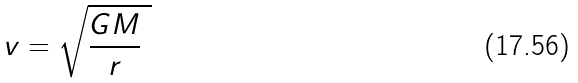Convert formula to latex. <formula><loc_0><loc_0><loc_500><loc_500>\ v = { \sqrt { { \frac { G M } { r } } \ } }</formula> 